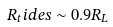Convert formula to latex. <formula><loc_0><loc_0><loc_500><loc_500>R _ { t } i d e s \sim 0 . 9 R _ { L }</formula> 